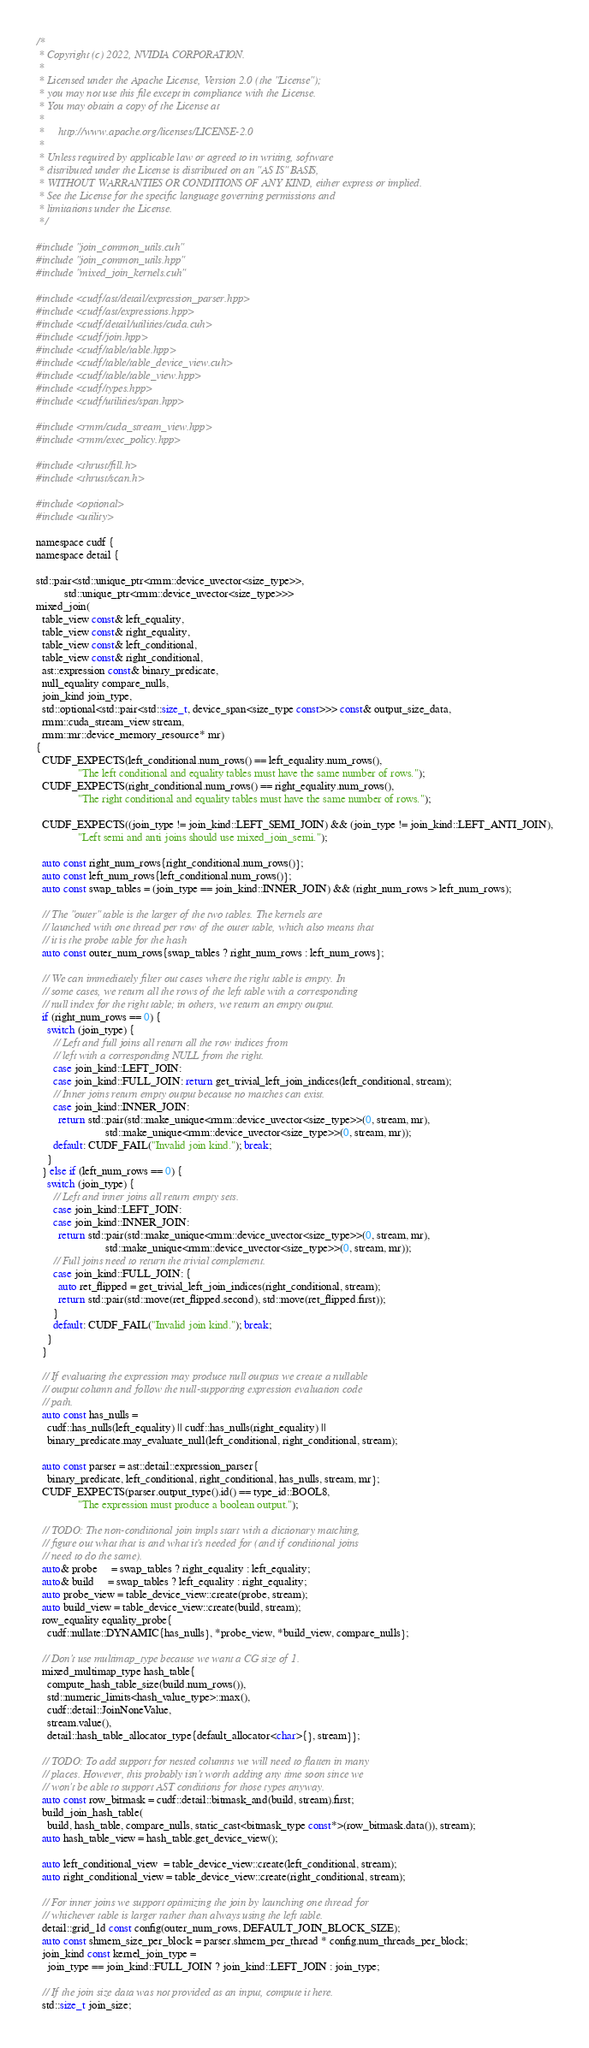<code> <loc_0><loc_0><loc_500><loc_500><_Cuda_>/*
 * Copyright (c) 2022, NVIDIA CORPORATION.
 *
 * Licensed under the Apache License, Version 2.0 (the "License");
 * you may not use this file except in compliance with the License.
 * You may obtain a copy of the License at
 *
 *     http://www.apache.org/licenses/LICENSE-2.0
 *
 * Unless required by applicable law or agreed to in writing, software
 * distributed under the License is distributed on an "AS IS" BASIS,
 * WITHOUT WARRANTIES OR CONDITIONS OF ANY KIND, either express or implied.
 * See the License for the specific language governing permissions and
 * limitations under the License.
 */

#include "join_common_utils.cuh"
#include "join_common_utils.hpp"
#include "mixed_join_kernels.cuh"

#include <cudf/ast/detail/expression_parser.hpp>
#include <cudf/ast/expressions.hpp>
#include <cudf/detail/utilities/cuda.cuh>
#include <cudf/join.hpp>
#include <cudf/table/table.hpp>
#include <cudf/table/table_device_view.cuh>
#include <cudf/table/table_view.hpp>
#include <cudf/types.hpp>
#include <cudf/utilities/span.hpp>

#include <rmm/cuda_stream_view.hpp>
#include <rmm/exec_policy.hpp>

#include <thrust/fill.h>
#include <thrust/scan.h>

#include <optional>
#include <utility>

namespace cudf {
namespace detail {

std::pair<std::unique_ptr<rmm::device_uvector<size_type>>,
          std::unique_ptr<rmm::device_uvector<size_type>>>
mixed_join(
  table_view const& left_equality,
  table_view const& right_equality,
  table_view const& left_conditional,
  table_view const& right_conditional,
  ast::expression const& binary_predicate,
  null_equality compare_nulls,
  join_kind join_type,
  std::optional<std::pair<std::size_t, device_span<size_type const>>> const& output_size_data,
  rmm::cuda_stream_view stream,
  rmm::mr::device_memory_resource* mr)
{
  CUDF_EXPECTS(left_conditional.num_rows() == left_equality.num_rows(),
               "The left conditional and equality tables must have the same number of rows.");
  CUDF_EXPECTS(right_conditional.num_rows() == right_equality.num_rows(),
               "The right conditional and equality tables must have the same number of rows.");

  CUDF_EXPECTS((join_type != join_kind::LEFT_SEMI_JOIN) && (join_type != join_kind::LEFT_ANTI_JOIN),
               "Left semi and anti joins should use mixed_join_semi.");

  auto const right_num_rows{right_conditional.num_rows()};
  auto const left_num_rows{left_conditional.num_rows()};
  auto const swap_tables = (join_type == join_kind::INNER_JOIN) && (right_num_rows > left_num_rows);

  // The "outer" table is the larger of the two tables. The kernels are
  // launched with one thread per row of the outer table, which also means that
  // it is the probe table for the hash
  auto const outer_num_rows{swap_tables ? right_num_rows : left_num_rows};

  // We can immediately filter out cases where the right table is empty. In
  // some cases, we return all the rows of the left table with a corresponding
  // null index for the right table; in others, we return an empty output.
  if (right_num_rows == 0) {
    switch (join_type) {
      // Left and full joins all return all the row indices from
      // left with a corresponding NULL from the right.
      case join_kind::LEFT_JOIN:
      case join_kind::FULL_JOIN: return get_trivial_left_join_indices(left_conditional, stream);
      // Inner joins return empty output because no matches can exist.
      case join_kind::INNER_JOIN:
        return std::pair(std::make_unique<rmm::device_uvector<size_type>>(0, stream, mr),
                         std::make_unique<rmm::device_uvector<size_type>>(0, stream, mr));
      default: CUDF_FAIL("Invalid join kind."); break;
    }
  } else if (left_num_rows == 0) {
    switch (join_type) {
      // Left and inner joins all return empty sets.
      case join_kind::LEFT_JOIN:
      case join_kind::INNER_JOIN:
        return std::pair(std::make_unique<rmm::device_uvector<size_type>>(0, stream, mr),
                         std::make_unique<rmm::device_uvector<size_type>>(0, stream, mr));
      // Full joins need to return the trivial complement.
      case join_kind::FULL_JOIN: {
        auto ret_flipped = get_trivial_left_join_indices(right_conditional, stream);
        return std::pair(std::move(ret_flipped.second), std::move(ret_flipped.first));
      }
      default: CUDF_FAIL("Invalid join kind."); break;
    }
  }

  // If evaluating the expression may produce null outputs we create a nullable
  // output column and follow the null-supporting expression evaluation code
  // path.
  auto const has_nulls =
    cudf::has_nulls(left_equality) || cudf::has_nulls(right_equality) ||
    binary_predicate.may_evaluate_null(left_conditional, right_conditional, stream);

  auto const parser = ast::detail::expression_parser{
    binary_predicate, left_conditional, right_conditional, has_nulls, stream, mr};
  CUDF_EXPECTS(parser.output_type().id() == type_id::BOOL8,
               "The expression must produce a boolean output.");

  // TODO: The non-conditional join impls start with a dictionary matching,
  // figure out what that is and what it's needed for (and if conditional joins
  // need to do the same).
  auto& probe     = swap_tables ? right_equality : left_equality;
  auto& build     = swap_tables ? left_equality : right_equality;
  auto probe_view = table_device_view::create(probe, stream);
  auto build_view = table_device_view::create(build, stream);
  row_equality equality_probe{
    cudf::nullate::DYNAMIC{has_nulls}, *probe_view, *build_view, compare_nulls};

  // Don't use multimap_type because we want a CG size of 1.
  mixed_multimap_type hash_table{
    compute_hash_table_size(build.num_rows()),
    std::numeric_limits<hash_value_type>::max(),
    cudf::detail::JoinNoneValue,
    stream.value(),
    detail::hash_table_allocator_type{default_allocator<char>{}, stream}};

  // TODO: To add support for nested columns we will need to flatten in many
  // places. However, this probably isn't worth adding any time soon since we
  // won't be able to support AST conditions for those types anyway.
  auto const row_bitmask = cudf::detail::bitmask_and(build, stream).first;
  build_join_hash_table(
    build, hash_table, compare_nulls, static_cast<bitmask_type const*>(row_bitmask.data()), stream);
  auto hash_table_view = hash_table.get_device_view();

  auto left_conditional_view  = table_device_view::create(left_conditional, stream);
  auto right_conditional_view = table_device_view::create(right_conditional, stream);

  // For inner joins we support optimizing the join by launching one thread for
  // whichever table is larger rather than always using the left table.
  detail::grid_1d const config(outer_num_rows, DEFAULT_JOIN_BLOCK_SIZE);
  auto const shmem_size_per_block = parser.shmem_per_thread * config.num_threads_per_block;
  join_kind const kernel_join_type =
    join_type == join_kind::FULL_JOIN ? join_kind::LEFT_JOIN : join_type;

  // If the join size data was not provided as an input, compute it here.
  std::size_t join_size;</code> 